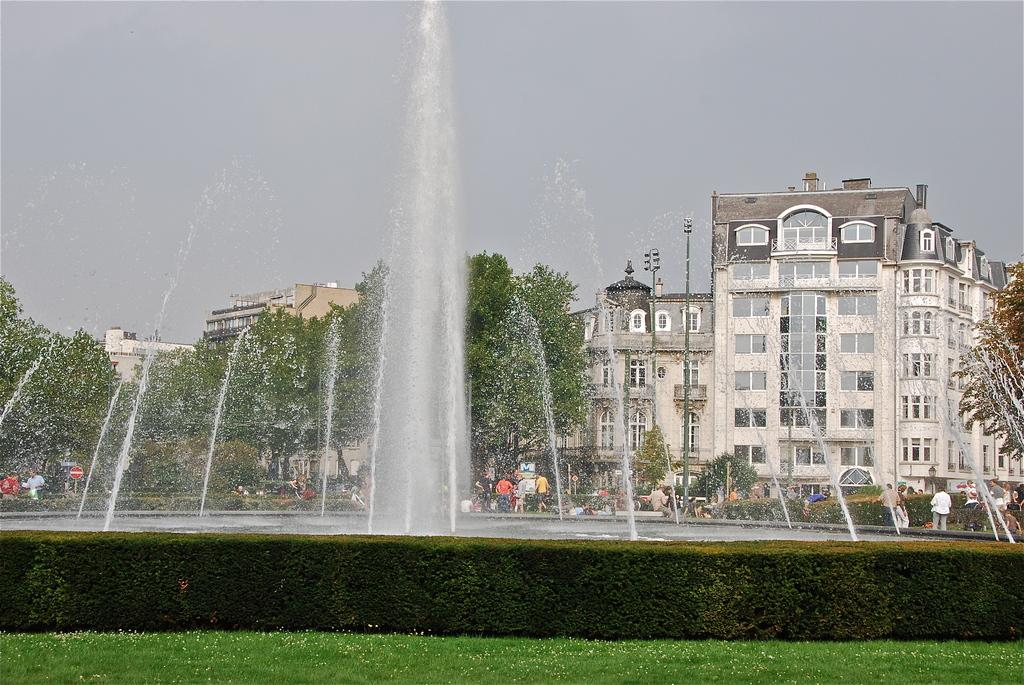What is the main feature in the image? There is a water fountain in the in the image. What type of vegetation can be seen in the image? There are bushes and trees in the image. Who or what is present in the image? There is a group of people in the image. What type of lighting is present in the image? There are lights in the image. What type of structures are visible in the image? There are poles and buildings in the image. What type of ground surface is visible in the image? There is grass in the image. What can be seen in the background of the image? The sky is visible in the background of the image. How many rocks are present in the image? There are no rocks visible in the image. What type of year is depicted in the image? The image does not depict a specific year; it is a still image without any time-related context. 